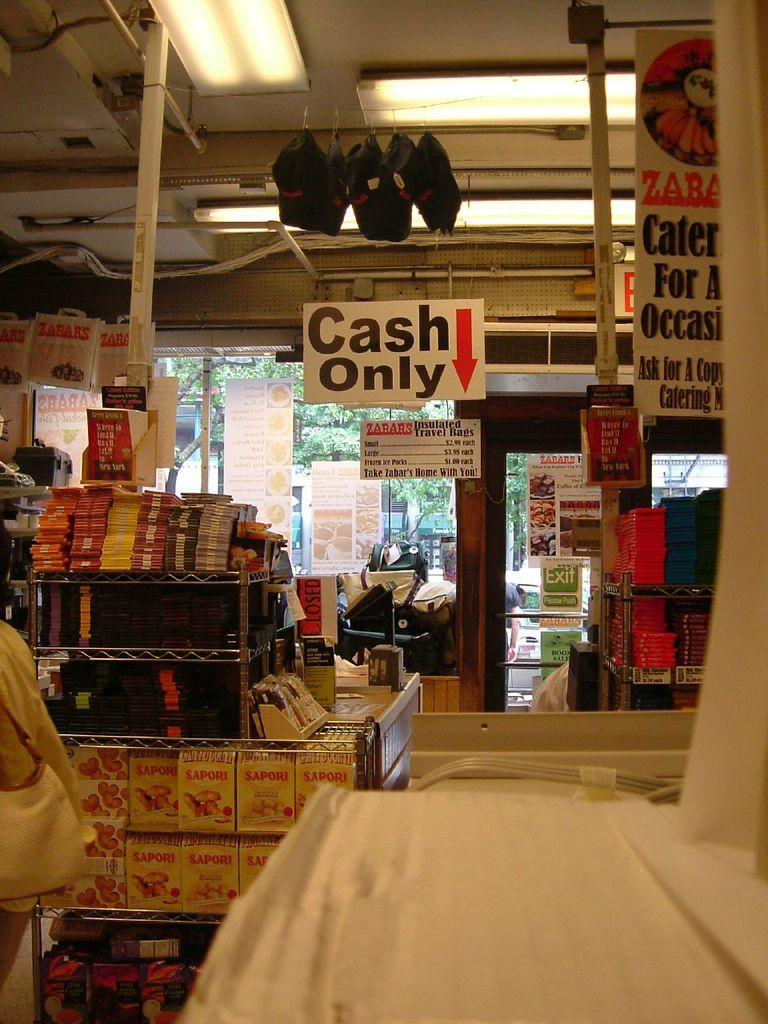Can you pay with a card?
Your answer should be very brief. No. What does the overhead sign say to use only of?
Make the answer very short. Cash. 